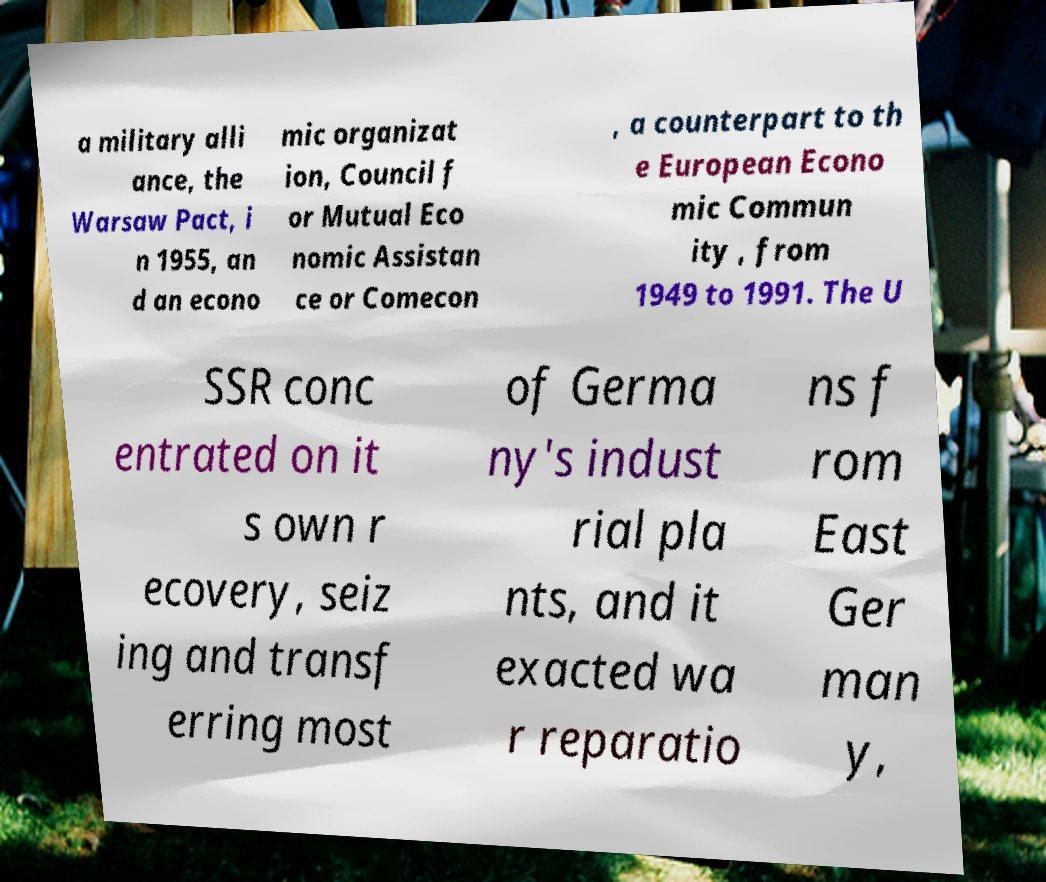There's text embedded in this image that I need extracted. Can you transcribe it verbatim? a military alli ance, the Warsaw Pact, i n 1955, an d an econo mic organizat ion, Council f or Mutual Eco nomic Assistan ce or Comecon , a counterpart to th e European Econo mic Commun ity , from 1949 to 1991. The U SSR conc entrated on it s own r ecovery, seiz ing and transf erring most of Germa ny's indust rial pla nts, and it exacted wa r reparatio ns f rom East Ger man y, 